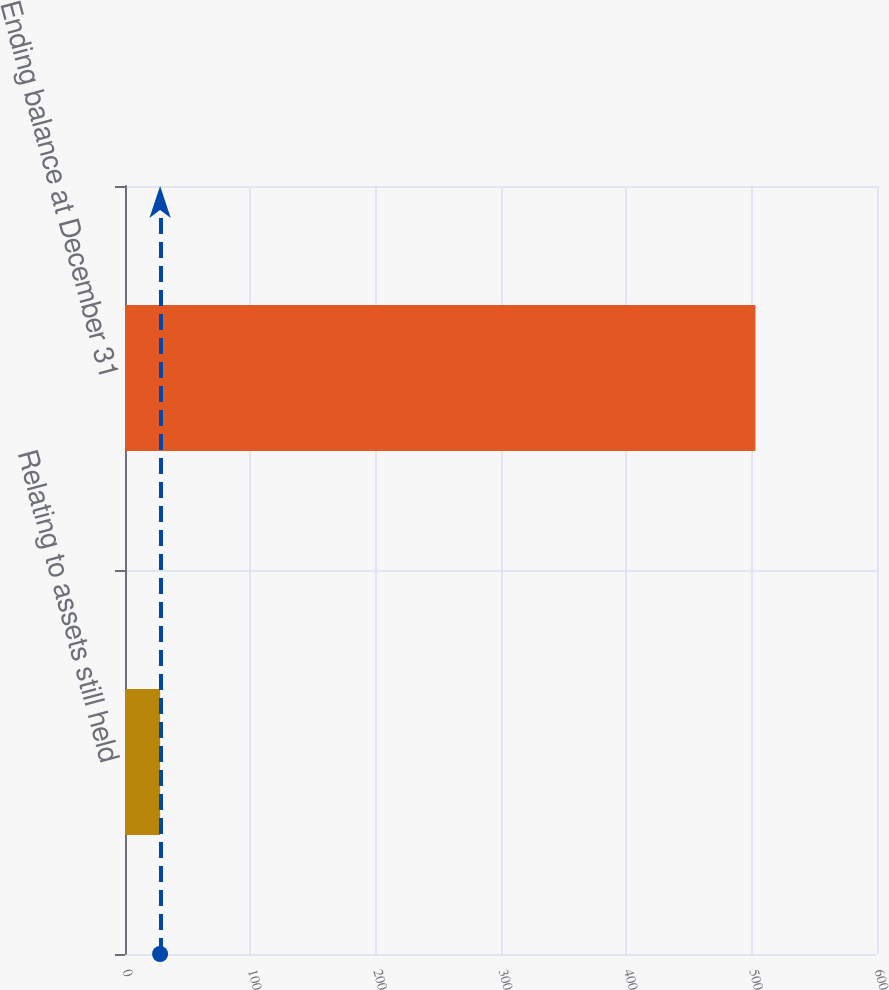Convert chart. <chart><loc_0><loc_0><loc_500><loc_500><bar_chart><fcel>Relating to assets still held<fcel>Ending balance at December 31<nl><fcel>28<fcel>503<nl></chart> 